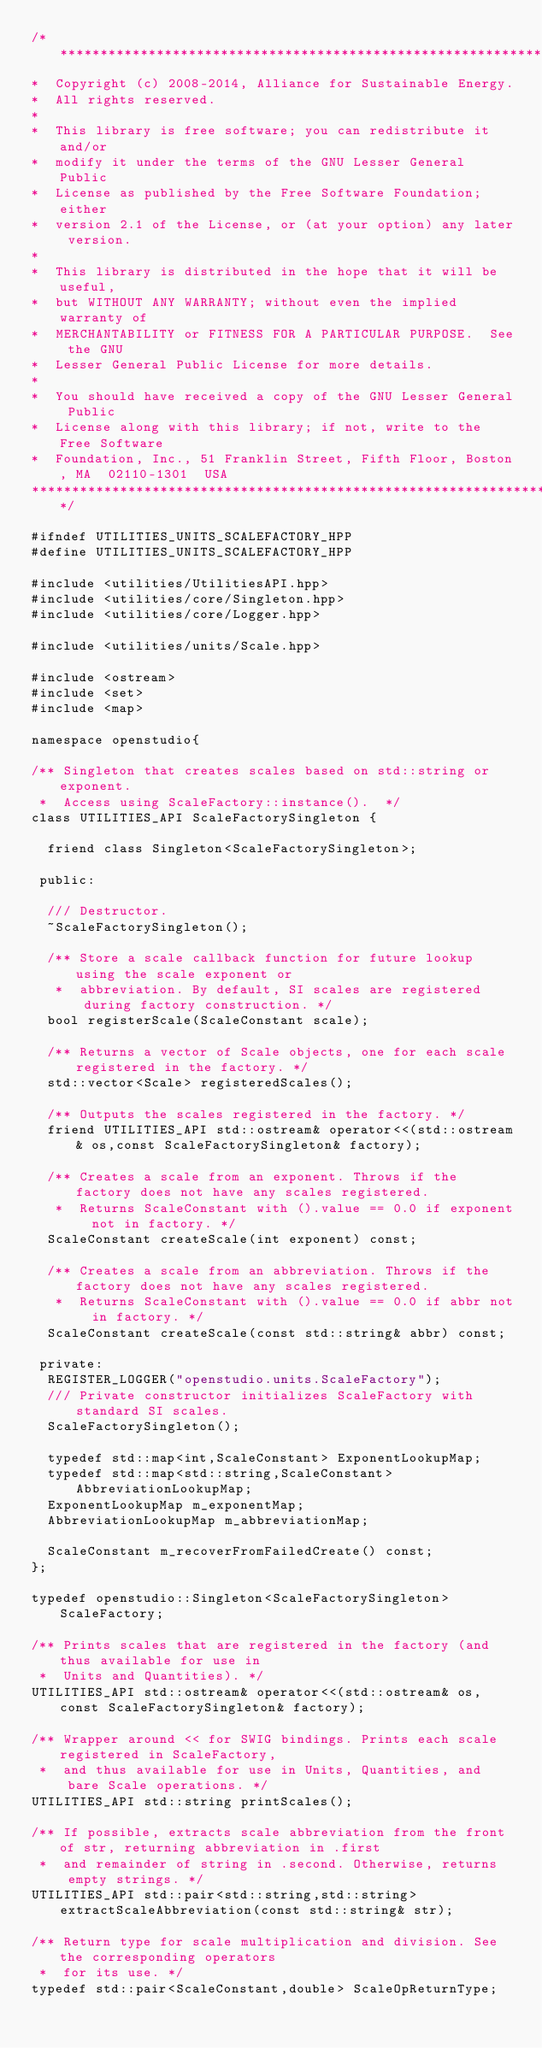<code> <loc_0><loc_0><loc_500><loc_500><_C++_>/**********************************************************************
*  Copyright (c) 2008-2014, Alliance for Sustainable Energy.  
*  All rights reserved.
*  
*  This library is free software; you can redistribute it and/or
*  modify it under the terms of the GNU Lesser General Public
*  License as published by the Free Software Foundation; either
*  version 2.1 of the License, or (at your option) any later version.
*  
*  This library is distributed in the hope that it will be useful,
*  but WITHOUT ANY WARRANTY; without even the implied warranty of
*  MERCHANTABILITY or FITNESS FOR A PARTICULAR PURPOSE.  See the GNU
*  Lesser General Public License for more details.
*  
*  You should have received a copy of the GNU Lesser General Public
*  License along with this library; if not, write to the Free Software
*  Foundation, Inc., 51 Franklin Street, Fifth Floor, Boston, MA  02110-1301  USA
**********************************************************************/

#ifndef UTILITIES_UNITS_SCALEFACTORY_HPP
#define UTILITIES_UNITS_SCALEFACTORY_HPP

#include <utilities/UtilitiesAPI.hpp>
#include <utilities/core/Singleton.hpp>
#include <utilities/core/Logger.hpp>

#include <utilities/units/Scale.hpp>

#include <ostream>
#include <set>
#include <map>

namespace openstudio{

/** Singleton that creates scales based on std::string or exponent. 
 *  Access using ScaleFactory::instance().  */
class UTILITIES_API ScaleFactorySingleton {

  friend class Singleton<ScaleFactorySingleton>;

 public:
  
  /// Destructor.
  ~ScaleFactorySingleton();

  /** Store a scale callback function for future lookup using the scale exponent or 
   *  abbreviation. By default, SI scales are registered during factory construction. */
  bool registerScale(ScaleConstant scale);

  /** Returns a vector of Scale objects, one for each scale registered in the factory. */
  std::vector<Scale> registeredScales();

  /** Outputs the scales registered in the factory. */
  friend UTILITIES_API std::ostream& operator<<(std::ostream& os,const ScaleFactorySingleton& factory);

  /** Creates a scale from an exponent. Throws if the factory does not have any scales registered. 
   *  Returns ScaleConstant with ().value == 0.0 if exponent not in factory. */
  ScaleConstant createScale(int exponent) const;

  /** Creates a scale from an abbreviation. Throws if the factory does not have any scales registered. 
   *  Returns ScaleConstant with ().value == 0.0 if abbr not in factory. */
  ScaleConstant createScale(const std::string& abbr) const;
  
 private:  
  REGISTER_LOGGER("openstudio.units.ScaleFactory");
  /// Private constructor initializes ScaleFactory with standard SI scales.
  ScaleFactorySingleton();

  typedef std::map<int,ScaleConstant> ExponentLookupMap;
  typedef std::map<std::string,ScaleConstant> AbbreviationLookupMap;
  ExponentLookupMap m_exponentMap;
  AbbreviationLookupMap m_abbreviationMap;

  ScaleConstant m_recoverFromFailedCreate() const;
};  

typedef openstudio::Singleton<ScaleFactorySingleton> ScaleFactory;

/** Prints scales that are registered in the factory (and thus available for use in 
 *  Units and Quantities). */
UTILITIES_API std::ostream& operator<<(std::ostream& os,const ScaleFactorySingleton& factory);

/** Wrapper around << for SWIG bindings. Prints each scale registered in ScaleFactory, 
 *  and thus available for use in Units, Quantities, and bare Scale operations. */
UTILITIES_API std::string printScales();

/** If possible, extracts scale abbreviation from the front of str, returning abbreviation in .first 
 *  and remainder of string in .second. Otherwise, returns empty strings. */
UTILITIES_API std::pair<std::string,std::string> extractScaleAbbreviation(const std::string& str);

/** Return type for scale multiplication and division. See the corresponding operators
 *  for its use. */
typedef std::pair<ScaleConstant,double> ScaleOpReturnType;
</code> 